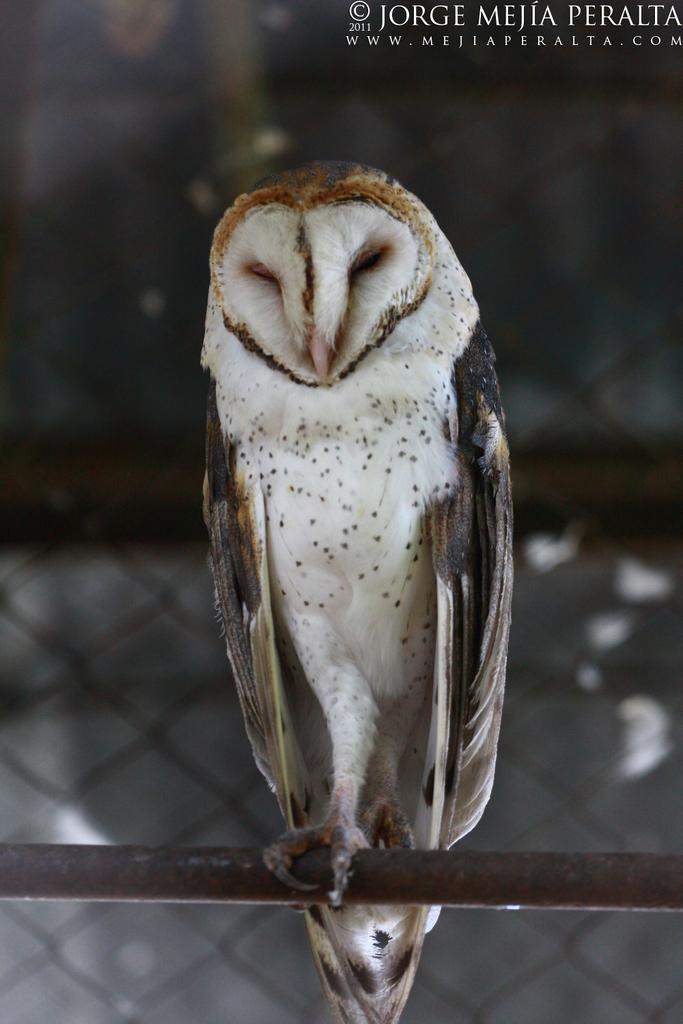Please provide a concise description of this image. In this picture there is an owl who is standing on this ride. In the background I can see fencing. In the top right corner there is a watermark. 